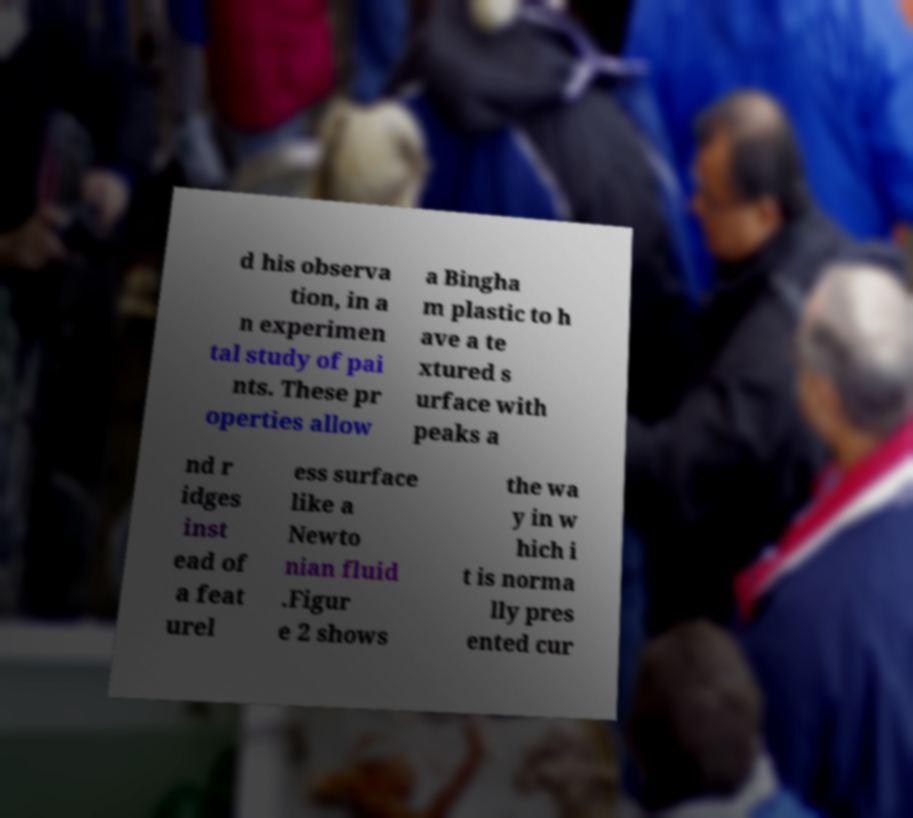Can you read and provide the text displayed in the image?This photo seems to have some interesting text. Can you extract and type it out for me? d his observa tion, in a n experimen tal study of pai nts. These pr operties allow a Bingha m plastic to h ave a te xtured s urface with peaks a nd r idges inst ead of a feat urel ess surface like a Newto nian fluid .Figur e 2 shows the wa y in w hich i t is norma lly pres ented cur 